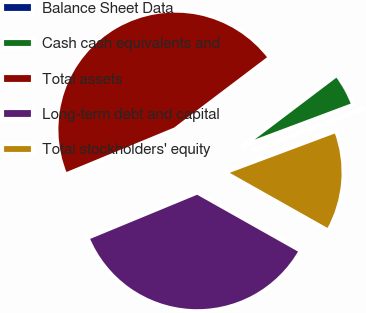Convert chart. <chart><loc_0><loc_0><loc_500><loc_500><pie_chart><fcel>Balance Sheet Data<fcel>Cash cash equivalents and<fcel>Total assets<fcel>Long-term debt and capital<fcel>Total stockholders' equity<nl><fcel>0.01%<fcel>4.61%<fcel>45.92%<fcel>35.6%<fcel>13.86%<nl></chart> 